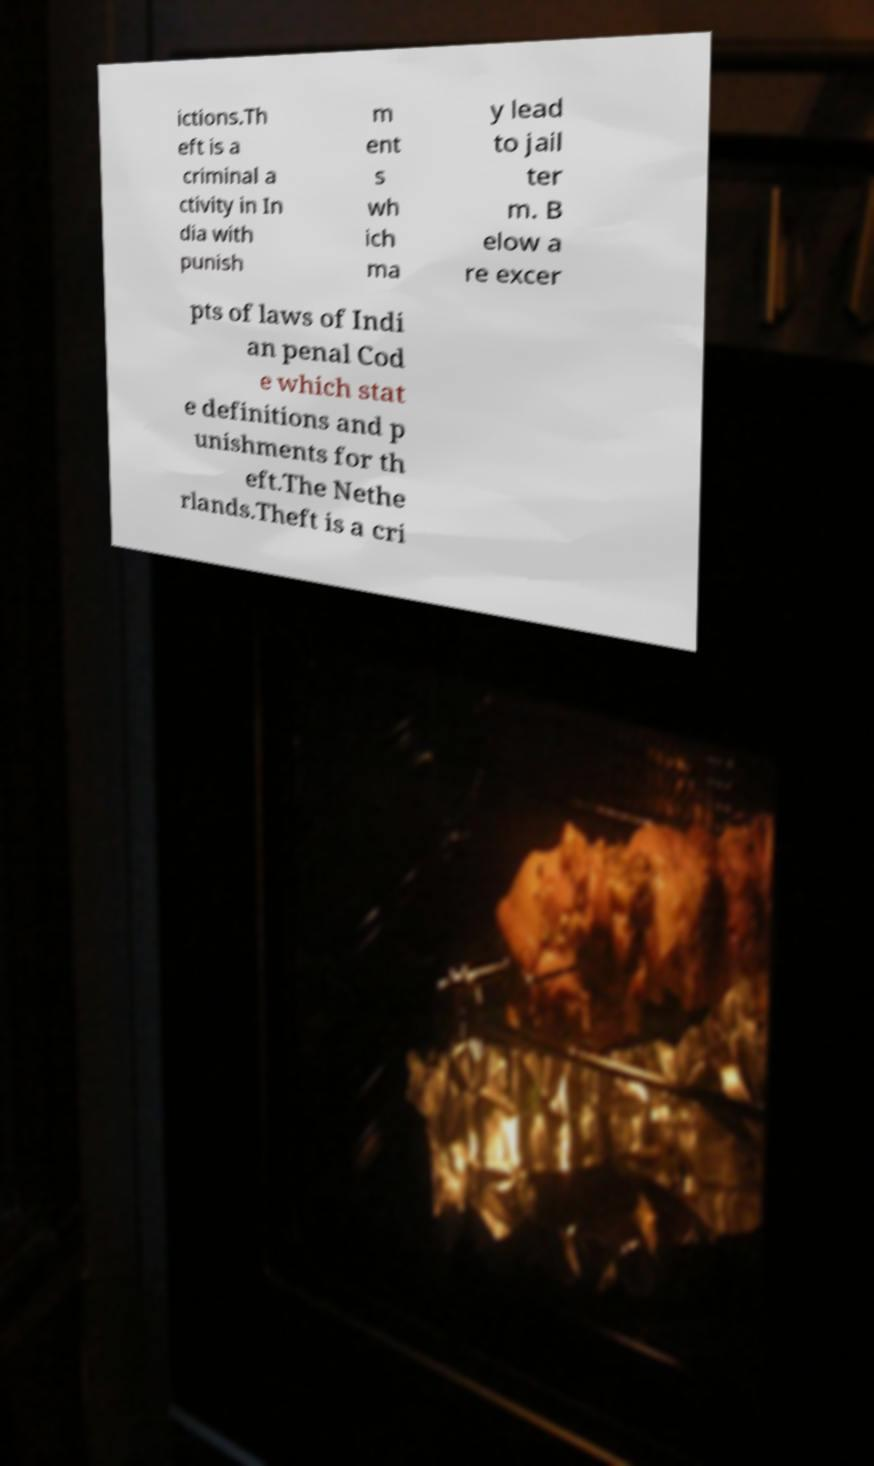I need the written content from this picture converted into text. Can you do that? ictions.Th eft is a criminal a ctivity in In dia with punish m ent s wh ich ma y lead to jail ter m. B elow a re excer pts of laws of Indi an penal Cod e which stat e definitions and p unishments for th eft.The Nethe rlands.Theft is a cri 